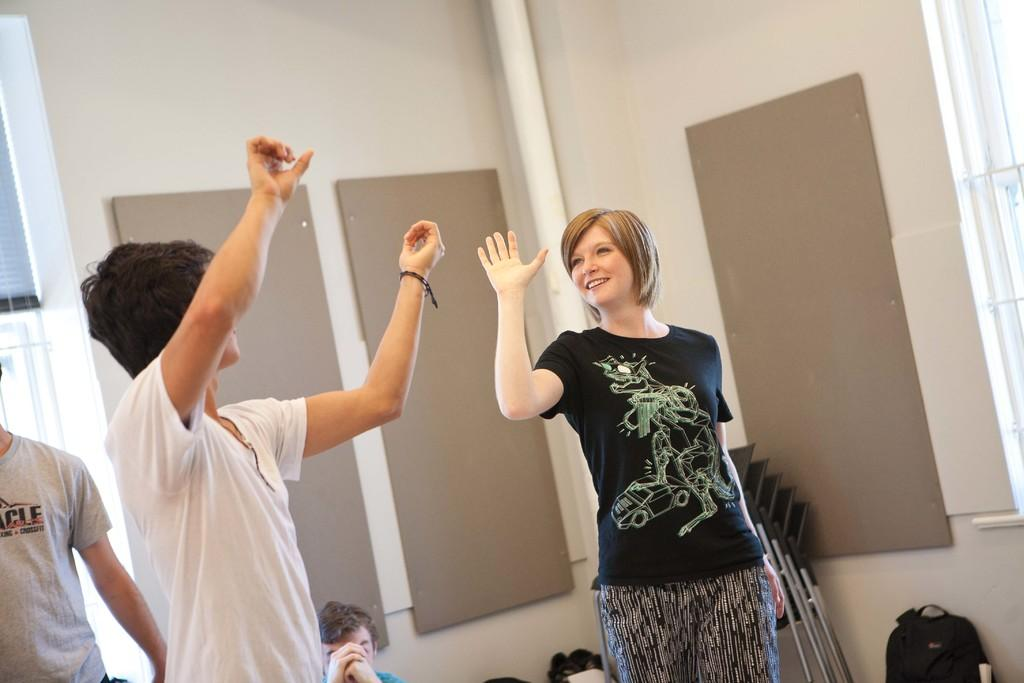Who can be seen in the foreground of the image? There is a man and a woman in the foreground of the image. What are the man and woman doing in the image? The man and woman have their hands up in the air. What can be seen in the background of the image? There are bags, chairs, a wall, a pipe, and a window blind in the background of the image. Are there any other people visible in the image? Yes, there are two men in the background of the image. What type of wine is the man holding in the image? There is no wine present in the image; the man and woman have their hands up in the air. Can you tell me how many brains are visible in the image? There are no brains visible in the image. 